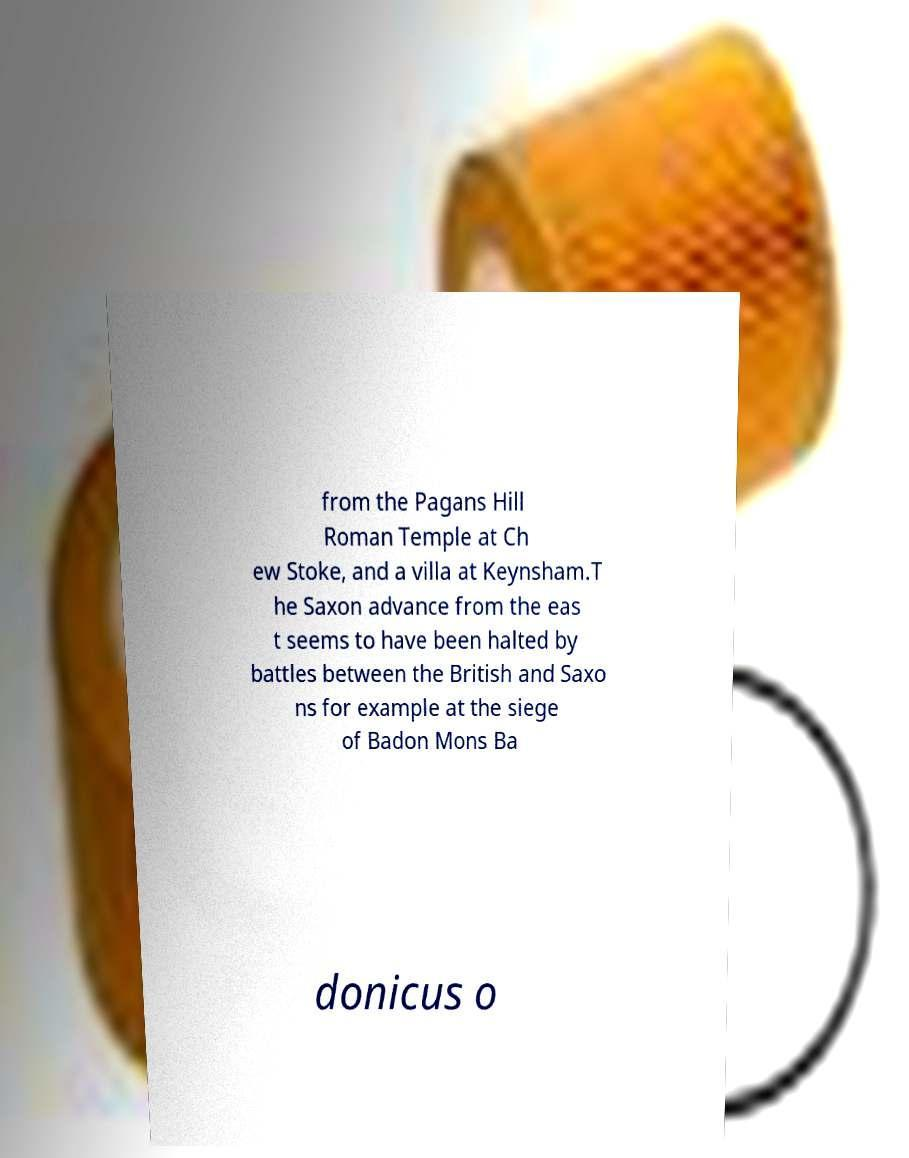Can you accurately transcribe the text from the provided image for me? from the Pagans Hill Roman Temple at Ch ew Stoke, and a villa at Keynsham.T he Saxon advance from the eas t seems to have been halted by battles between the British and Saxo ns for example at the siege of Badon Mons Ba donicus o 